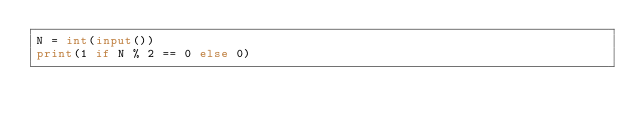<code> <loc_0><loc_0><loc_500><loc_500><_Python_>N = int(input())
print(1 if N % 2 == 0 else 0)
</code> 